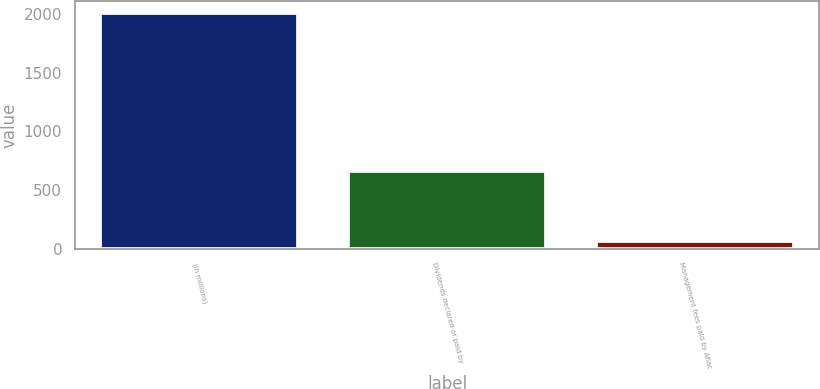Convert chart. <chart><loc_0><loc_0><loc_500><loc_500><bar_chart><fcel>(In millions)<fcel>Dividends declared or paid by<fcel>Management fees paid by Aflac<nl><fcel>2006<fcel>665<fcel>68<nl></chart> 